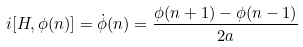Convert formula to latex. <formula><loc_0><loc_0><loc_500><loc_500>i [ H , \phi ( n ) ] = \dot { \phi } ( n ) = \frac { \phi ( n + 1 ) - \phi ( n - 1 ) } { 2 a }</formula> 